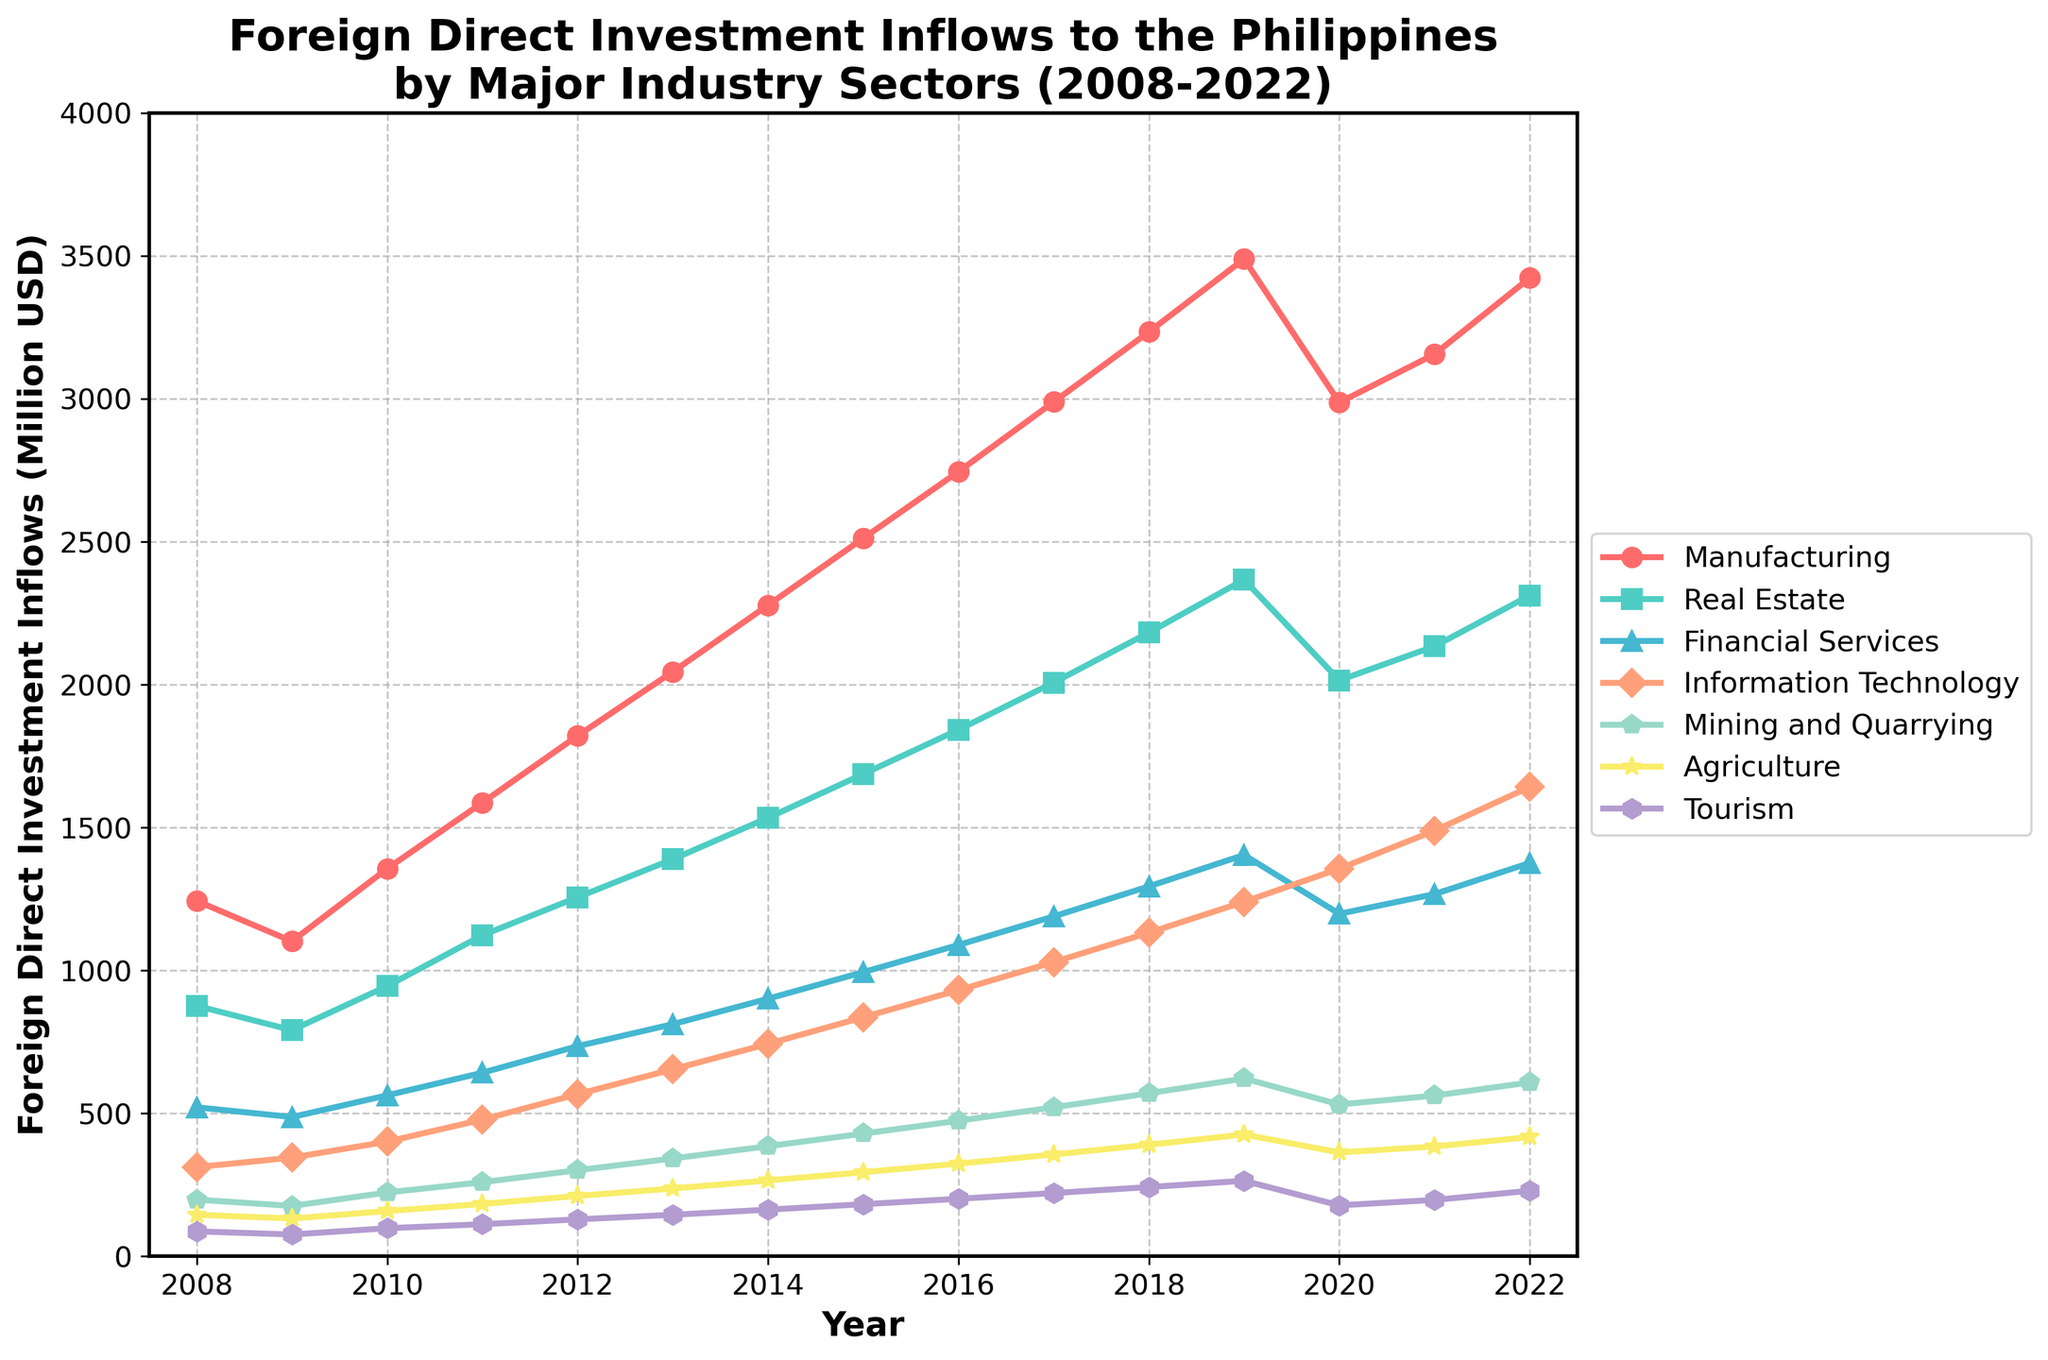Which sector had the highest FDI inflow in 2022? To find this, look at the data points for each sector in 2022 and identify the highest one. From the chart, manufacturing had the highest FDI inflow.
Answer: Manufacturing What was the FDI inflow for the Financial Services sector in 2020 compared to 2018? Check the data points for the Financial Services sector in 2020 and 2018 from the chart. The FDI inflow in 2020 was lower compared to 2018.
Answer: 1198 in 2020, 1294 in 2018 Which sector experienced the biggest increase in FDI inflows between 2008 and 2022? Calculate the difference between the FDI inflows of 2022 and 2008 for each sector, then identify the sector with the highest increase. Manufacturing had the biggest increase (3423 - 1243 = 2180).
Answer: Manufacturing Did any sector experience a decline in FDI inflows in any year from 2008 to 2022? Look at the trend lines for each sector to identify if any had a negative slope at any point. The Real Estate sector experienced a decline in 2020 compared to 2019.
Answer: Real Estate What is the average FDI inflow into the Information Technology sector over the last 15 years? Sum the FDI inflows for the Information Technology sector from 2008 to 2022 and then divide by 15. The calculation is (312 + 345 + 401 + 478 + 567 + 654 + 743 + 836 + 931 + 1029 + 1132 + 1240 + 1356 + 1489 + 1642) / 15 which equals 891.33.
Answer: 891.33 Which year saw the highest total FDI inflows across all sectors? Sum the FDI inflows for all sectors for each year and identify the year with the highest total. The sums for each year should be calculated and compared. 2019 saw the highest total FDI inflow.
Answer: 2019 How did the inflows for the Mining and Quarrying sector change between 2010 and 2015? Check the data points for the Mining and Quarrying sector in both 2010 and 2015. The inflow increased from 223 to 429.
Answer: Increased Which year saw the Tourism sector reach over 200 million USD in FDI inflows for the first time? Review the data points for the Tourism sector year by year to identify when it first surpassed 200 million USD. It first reached over 200 million USD in 2016.
Answer: 2016 Compare the FDI trends between the Agriculture and Mining and Quarrying sectors. Observe the overall trend lines for both Agriculture and Mining and Quarrying sectors throughout the years. Both sectors show an increasing trend, but Mining and Quarrying had larger inflows and a steeper increase over the years.
Answer: Mining and Quarrying had larger inflows and a steeper increase What's the total FDI inflow for the Real Estate sector over the entire period? Sum the FDI inflows of the Real Estate sector from 2008 to 2022. The total is calculated as (876 + 791 + 945 + 1123 + 1256 + 1389 + 1534 + 1687 + 1842 + 2007 + 2182 + 2367 + 2015 + 2134 + 2312) = 27360.
Answer: 27360 